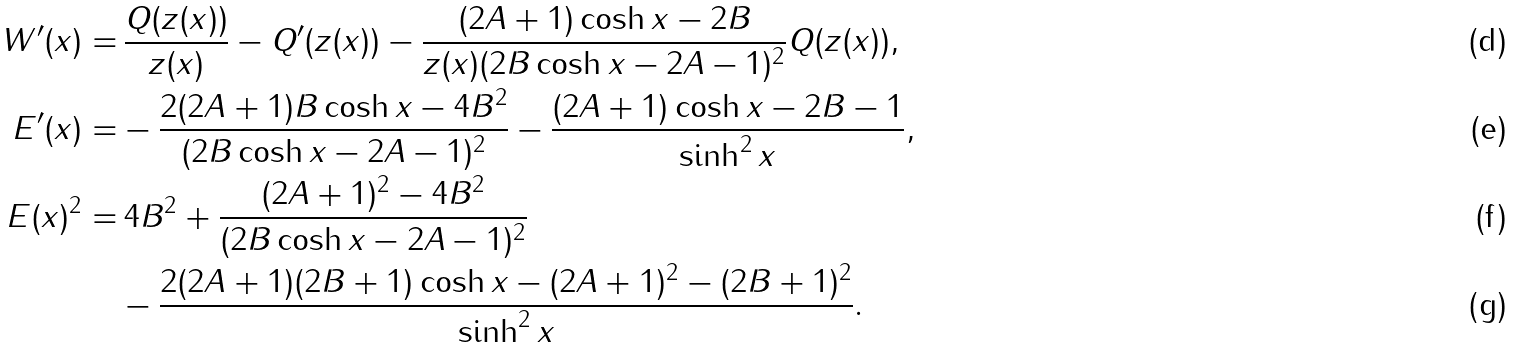Convert formula to latex. <formula><loc_0><loc_0><loc_500><loc_500>W ^ { \prime } ( x ) = & \, \frac { Q ( z ( x ) ) } { z ( x ) } - Q ^ { \prime } ( z ( x ) ) - \frac { ( 2 A + 1 ) \cosh x - 2 B } { z ( x ) ( 2 B \cosh x - 2 A - 1 ) ^ { 2 } } Q ( z ( x ) ) , \\ E ^ { \prime } ( x ) = & - \frac { 2 ( 2 A + 1 ) B \cosh x - 4 B ^ { 2 } } { ( 2 B \cosh x - 2 A - 1 ) ^ { 2 } } - \frac { ( 2 A + 1 ) \cosh x - 2 B - 1 } { \sinh ^ { 2 } x } , \\ E ( x ) ^ { 2 } = & \, 4 B ^ { 2 } + \frac { ( 2 A + 1 ) ^ { 2 } - 4 B ^ { 2 } } { ( 2 B \cosh x - 2 A - 1 ) ^ { 2 } } \\ & - \frac { 2 ( 2 A + 1 ) ( 2 B + 1 ) \cosh x - ( 2 A + 1 ) ^ { 2 } - ( 2 B + 1 ) ^ { 2 } } { \sinh ^ { 2 } x } .</formula> 